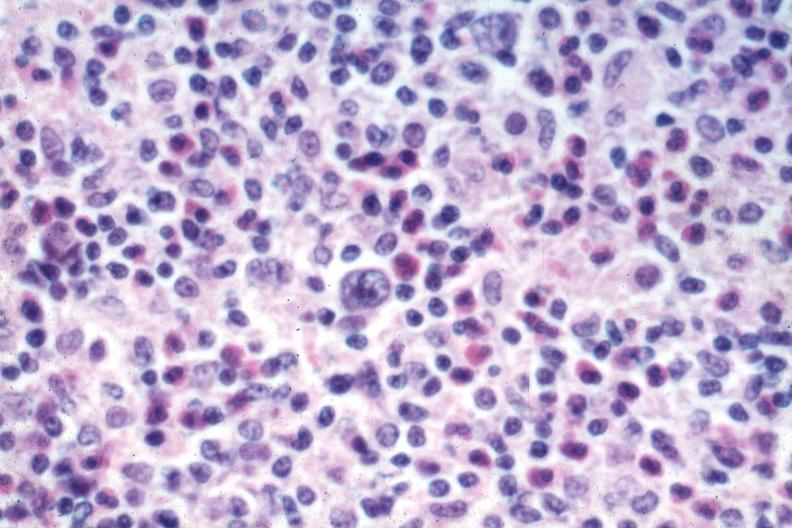s lymph node present?
Answer the question using a single word or phrase. Yes 